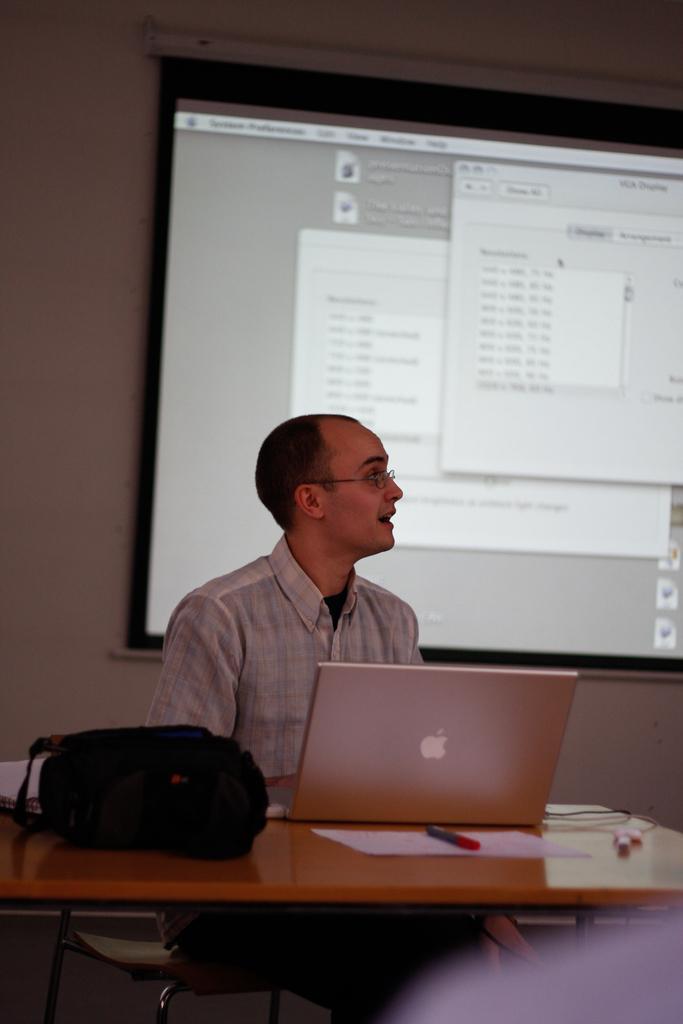Could you give a brief overview of what you see in this image? In this image there is a man sitting in chair , and on table there are laptop, bag, pen, papers and the back ground there is screen , wall. 